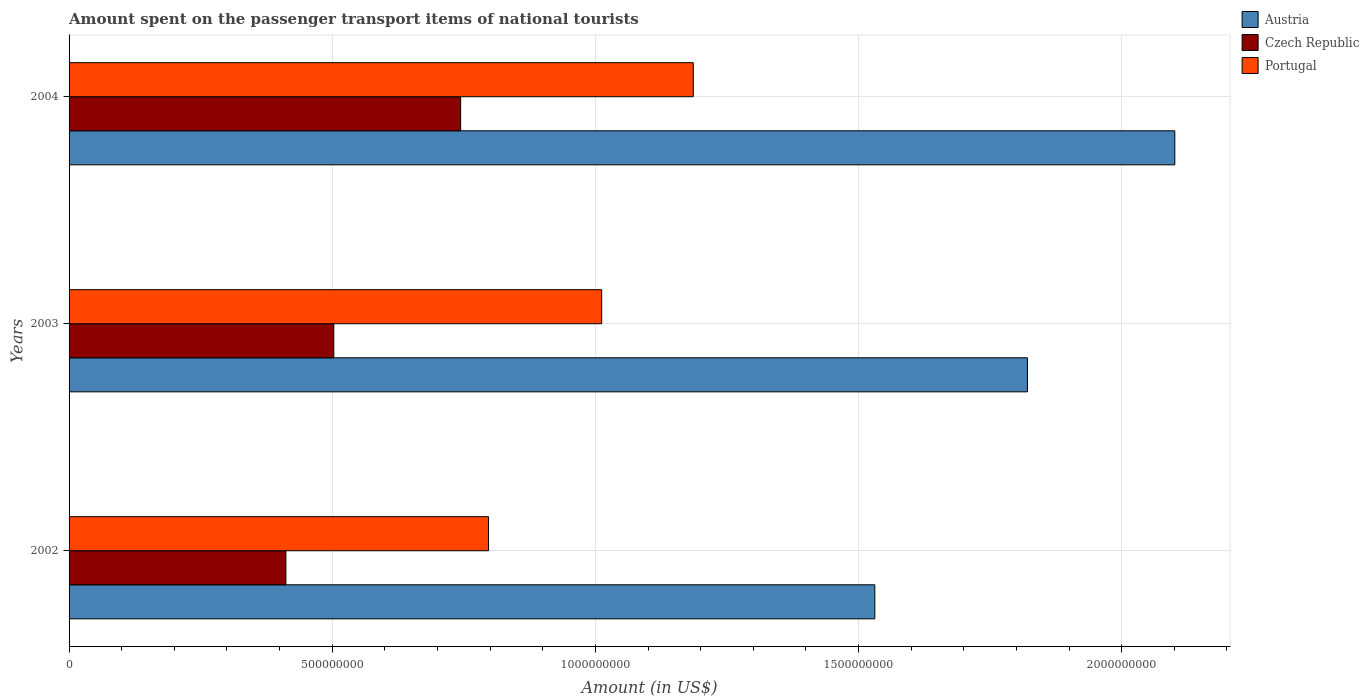How many different coloured bars are there?
Provide a succinct answer. 3. How many groups of bars are there?
Provide a succinct answer. 3. Are the number of bars per tick equal to the number of legend labels?
Give a very brief answer. Yes. Are the number of bars on each tick of the Y-axis equal?
Offer a very short reply. Yes. How many bars are there on the 2nd tick from the top?
Offer a very short reply. 3. How many bars are there on the 1st tick from the bottom?
Give a very brief answer. 3. What is the amount spent on the passenger transport items of national tourists in Czech Republic in 2003?
Make the answer very short. 5.03e+08. Across all years, what is the maximum amount spent on the passenger transport items of national tourists in Austria?
Ensure brevity in your answer.  2.10e+09. Across all years, what is the minimum amount spent on the passenger transport items of national tourists in Portugal?
Your answer should be compact. 7.97e+08. What is the total amount spent on the passenger transport items of national tourists in Austria in the graph?
Make the answer very short. 5.45e+09. What is the difference between the amount spent on the passenger transport items of national tourists in Czech Republic in 2003 and that in 2004?
Offer a very short reply. -2.41e+08. What is the difference between the amount spent on the passenger transport items of national tourists in Portugal in 2004 and the amount spent on the passenger transport items of national tourists in Czech Republic in 2002?
Provide a short and direct response. 7.74e+08. What is the average amount spent on the passenger transport items of national tourists in Czech Republic per year?
Your response must be concise. 5.53e+08. In the year 2003, what is the difference between the amount spent on the passenger transport items of national tourists in Austria and amount spent on the passenger transport items of national tourists in Czech Republic?
Keep it short and to the point. 1.32e+09. In how many years, is the amount spent on the passenger transport items of national tourists in Austria greater than 1100000000 US$?
Offer a very short reply. 3. What is the ratio of the amount spent on the passenger transport items of national tourists in Portugal in 2002 to that in 2004?
Your answer should be compact. 0.67. Is the difference between the amount spent on the passenger transport items of national tourists in Austria in 2002 and 2004 greater than the difference between the amount spent on the passenger transport items of national tourists in Czech Republic in 2002 and 2004?
Keep it short and to the point. No. What is the difference between the highest and the second highest amount spent on the passenger transport items of national tourists in Austria?
Ensure brevity in your answer.  2.80e+08. What is the difference between the highest and the lowest amount spent on the passenger transport items of national tourists in Czech Republic?
Keep it short and to the point. 3.32e+08. In how many years, is the amount spent on the passenger transport items of national tourists in Portugal greater than the average amount spent on the passenger transport items of national tourists in Portugal taken over all years?
Ensure brevity in your answer.  2. What does the 3rd bar from the top in 2003 represents?
Your response must be concise. Austria. How many bars are there?
Your answer should be very brief. 9. Are all the bars in the graph horizontal?
Keep it short and to the point. Yes. What is the difference between two consecutive major ticks on the X-axis?
Ensure brevity in your answer.  5.00e+08. Are the values on the major ticks of X-axis written in scientific E-notation?
Make the answer very short. No. Where does the legend appear in the graph?
Your answer should be compact. Top right. What is the title of the graph?
Offer a terse response. Amount spent on the passenger transport items of national tourists. What is the label or title of the Y-axis?
Offer a very short reply. Years. What is the Amount (in US$) in Austria in 2002?
Make the answer very short. 1.53e+09. What is the Amount (in US$) of Czech Republic in 2002?
Offer a very short reply. 4.12e+08. What is the Amount (in US$) of Portugal in 2002?
Your answer should be very brief. 7.97e+08. What is the Amount (in US$) in Austria in 2003?
Provide a succinct answer. 1.82e+09. What is the Amount (in US$) in Czech Republic in 2003?
Keep it short and to the point. 5.03e+08. What is the Amount (in US$) of Portugal in 2003?
Ensure brevity in your answer.  1.01e+09. What is the Amount (in US$) of Austria in 2004?
Your answer should be very brief. 2.10e+09. What is the Amount (in US$) of Czech Republic in 2004?
Your response must be concise. 7.44e+08. What is the Amount (in US$) of Portugal in 2004?
Your response must be concise. 1.19e+09. Across all years, what is the maximum Amount (in US$) of Austria?
Your answer should be very brief. 2.10e+09. Across all years, what is the maximum Amount (in US$) in Czech Republic?
Give a very brief answer. 7.44e+08. Across all years, what is the maximum Amount (in US$) in Portugal?
Offer a very short reply. 1.19e+09. Across all years, what is the minimum Amount (in US$) in Austria?
Your answer should be compact. 1.53e+09. Across all years, what is the minimum Amount (in US$) of Czech Republic?
Keep it short and to the point. 4.12e+08. Across all years, what is the minimum Amount (in US$) of Portugal?
Offer a terse response. 7.97e+08. What is the total Amount (in US$) in Austria in the graph?
Offer a terse response. 5.45e+09. What is the total Amount (in US$) of Czech Republic in the graph?
Provide a short and direct response. 1.66e+09. What is the total Amount (in US$) of Portugal in the graph?
Your answer should be compact. 3.00e+09. What is the difference between the Amount (in US$) of Austria in 2002 and that in 2003?
Provide a succinct answer. -2.90e+08. What is the difference between the Amount (in US$) in Czech Republic in 2002 and that in 2003?
Provide a succinct answer. -9.10e+07. What is the difference between the Amount (in US$) of Portugal in 2002 and that in 2003?
Give a very brief answer. -2.15e+08. What is the difference between the Amount (in US$) in Austria in 2002 and that in 2004?
Offer a terse response. -5.70e+08. What is the difference between the Amount (in US$) of Czech Republic in 2002 and that in 2004?
Offer a terse response. -3.32e+08. What is the difference between the Amount (in US$) in Portugal in 2002 and that in 2004?
Provide a succinct answer. -3.89e+08. What is the difference between the Amount (in US$) in Austria in 2003 and that in 2004?
Make the answer very short. -2.80e+08. What is the difference between the Amount (in US$) in Czech Republic in 2003 and that in 2004?
Your answer should be very brief. -2.41e+08. What is the difference between the Amount (in US$) in Portugal in 2003 and that in 2004?
Ensure brevity in your answer.  -1.74e+08. What is the difference between the Amount (in US$) in Austria in 2002 and the Amount (in US$) in Czech Republic in 2003?
Give a very brief answer. 1.03e+09. What is the difference between the Amount (in US$) of Austria in 2002 and the Amount (in US$) of Portugal in 2003?
Your answer should be very brief. 5.19e+08. What is the difference between the Amount (in US$) in Czech Republic in 2002 and the Amount (in US$) in Portugal in 2003?
Your answer should be compact. -6.00e+08. What is the difference between the Amount (in US$) of Austria in 2002 and the Amount (in US$) of Czech Republic in 2004?
Your response must be concise. 7.87e+08. What is the difference between the Amount (in US$) in Austria in 2002 and the Amount (in US$) in Portugal in 2004?
Offer a terse response. 3.45e+08. What is the difference between the Amount (in US$) in Czech Republic in 2002 and the Amount (in US$) in Portugal in 2004?
Provide a short and direct response. -7.74e+08. What is the difference between the Amount (in US$) of Austria in 2003 and the Amount (in US$) of Czech Republic in 2004?
Your response must be concise. 1.08e+09. What is the difference between the Amount (in US$) of Austria in 2003 and the Amount (in US$) of Portugal in 2004?
Provide a short and direct response. 6.35e+08. What is the difference between the Amount (in US$) of Czech Republic in 2003 and the Amount (in US$) of Portugal in 2004?
Offer a terse response. -6.83e+08. What is the average Amount (in US$) of Austria per year?
Your answer should be very brief. 1.82e+09. What is the average Amount (in US$) in Czech Republic per year?
Your response must be concise. 5.53e+08. What is the average Amount (in US$) of Portugal per year?
Your answer should be very brief. 9.98e+08. In the year 2002, what is the difference between the Amount (in US$) of Austria and Amount (in US$) of Czech Republic?
Your answer should be compact. 1.12e+09. In the year 2002, what is the difference between the Amount (in US$) in Austria and Amount (in US$) in Portugal?
Your answer should be very brief. 7.34e+08. In the year 2002, what is the difference between the Amount (in US$) in Czech Republic and Amount (in US$) in Portugal?
Ensure brevity in your answer.  -3.85e+08. In the year 2003, what is the difference between the Amount (in US$) of Austria and Amount (in US$) of Czech Republic?
Your answer should be very brief. 1.32e+09. In the year 2003, what is the difference between the Amount (in US$) of Austria and Amount (in US$) of Portugal?
Your answer should be compact. 8.09e+08. In the year 2003, what is the difference between the Amount (in US$) in Czech Republic and Amount (in US$) in Portugal?
Offer a terse response. -5.09e+08. In the year 2004, what is the difference between the Amount (in US$) of Austria and Amount (in US$) of Czech Republic?
Your answer should be very brief. 1.36e+09. In the year 2004, what is the difference between the Amount (in US$) in Austria and Amount (in US$) in Portugal?
Keep it short and to the point. 9.15e+08. In the year 2004, what is the difference between the Amount (in US$) of Czech Republic and Amount (in US$) of Portugal?
Give a very brief answer. -4.42e+08. What is the ratio of the Amount (in US$) of Austria in 2002 to that in 2003?
Your response must be concise. 0.84. What is the ratio of the Amount (in US$) of Czech Republic in 2002 to that in 2003?
Your answer should be very brief. 0.82. What is the ratio of the Amount (in US$) in Portugal in 2002 to that in 2003?
Your response must be concise. 0.79. What is the ratio of the Amount (in US$) of Austria in 2002 to that in 2004?
Make the answer very short. 0.73. What is the ratio of the Amount (in US$) of Czech Republic in 2002 to that in 2004?
Your answer should be very brief. 0.55. What is the ratio of the Amount (in US$) in Portugal in 2002 to that in 2004?
Your answer should be very brief. 0.67. What is the ratio of the Amount (in US$) of Austria in 2003 to that in 2004?
Offer a terse response. 0.87. What is the ratio of the Amount (in US$) of Czech Republic in 2003 to that in 2004?
Provide a short and direct response. 0.68. What is the ratio of the Amount (in US$) in Portugal in 2003 to that in 2004?
Give a very brief answer. 0.85. What is the difference between the highest and the second highest Amount (in US$) of Austria?
Ensure brevity in your answer.  2.80e+08. What is the difference between the highest and the second highest Amount (in US$) of Czech Republic?
Provide a short and direct response. 2.41e+08. What is the difference between the highest and the second highest Amount (in US$) in Portugal?
Your answer should be compact. 1.74e+08. What is the difference between the highest and the lowest Amount (in US$) of Austria?
Make the answer very short. 5.70e+08. What is the difference between the highest and the lowest Amount (in US$) of Czech Republic?
Provide a succinct answer. 3.32e+08. What is the difference between the highest and the lowest Amount (in US$) in Portugal?
Ensure brevity in your answer.  3.89e+08. 